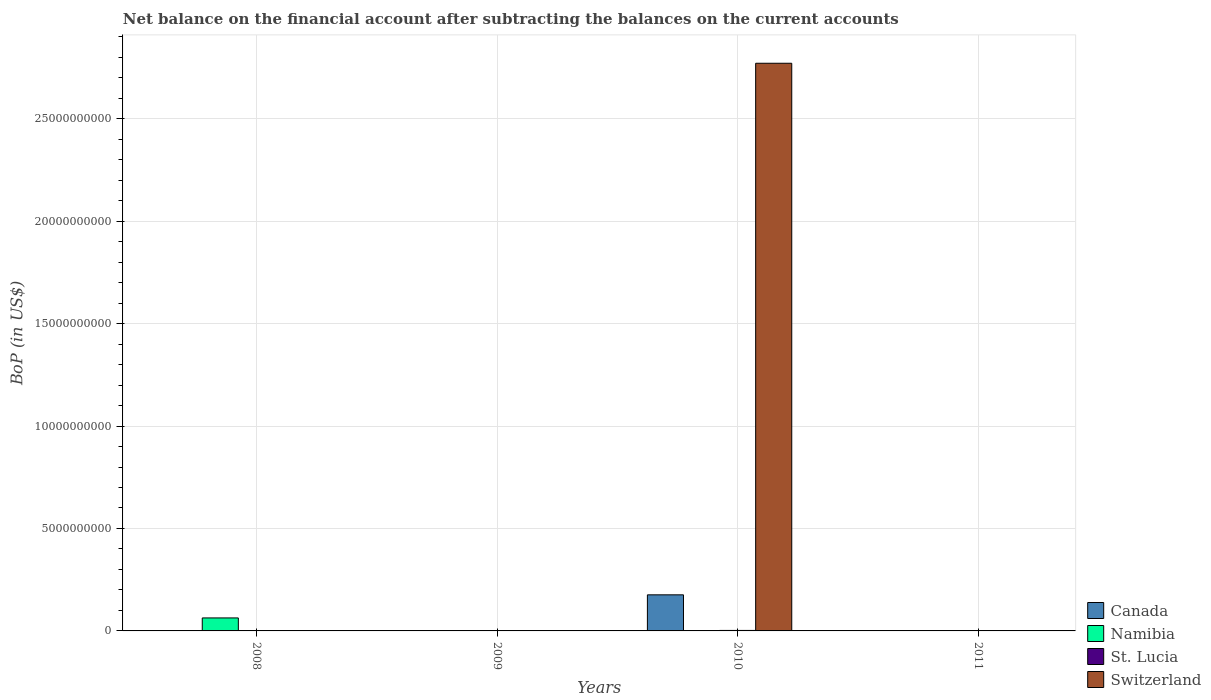Are the number of bars on each tick of the X-axis equal?
Your response must be concise. No. How many bars are there on the 3rd tick from the right?
Make the answer very short. 0. In how many cases, is the number of bars for a given year not equal to the number of legend labels?
Ensure brevity in your answer.  4. Across all years, what is the maximum Balance of Payments in Canada?
Your answer should be very brief. 1.76e+09. Across all years, what is the minimum Balance of Payments in Switzerland?
Your response must be concise. 0. In which year was the Balance of Payments in St. Lucia maximum?
Ensure brevity in your answer.  2010. What is the total Balance of Payments in Namibia in the graph?
Provide a short and direct response. 6.34e+08. What is the difference between the Balance of Payments in St. Lucia in 2011 and the Balance of Payments in Switzerland in 2010?
Provide a succinct answer. -2.77e+1. What is the average Balance of Payments in St. Lucia per year?
Offer a terse response. 8.04e+06. In the year 2010, what is the difference between the Balance of Payments in St. Lucia and Balance of Payments in Canada?
Provide a succinct answer. -1.74e+09. In how many years, is the Balance of Payments in St. Lucia greater than 14000000000 US$?
Provide a short and direct response. 0. Is the Balance of Payments in St. Lucia in 2010 less than that in 2011?
Offer a terse response. No. What is the difference between the highest and the lowest Balance of Payments in Canada?
Offer a terse response. 1.76e+09. Is it the case that in every year, the sum of the Balance of Payments in St. Lucia and Balance of Payments in Canada is greater than the Balance of Payments in Switzerland?
Offer a terse response. No. Where does the legend appear in the graph?
Your answer should be compact. Bottom right. How many legend labels are there?
Ensure brevity in your answer.  4. How are the legend labels stacked?
Make the answer very short. Vertical. What is the title of the graph?
Your answer should be compact. Net balance on the financial account after subtracting the balances on the current accounts. Does "United Kingdom" appear as one of the legend labels in the graph?
Keep it short and to the point. No. What is the label or title of the X-axis?
Your response must be concise. Years. What is the label or title of the Y-axis?
Provide a short and direct response. BoP (in US$). What is the BoP (in US$) of Canada in 2008?
Make the answer very short. 0. What is the BoP (in US$) in Namibia in 2008?
Your response must be concise. 6.34e+08. What is the BoP (in US$) in St. Lucia in 2008?
Ensure brevity in your answer.  0. What is the BoP (in US$) in Namibia in 2009?
Ensure brevity in your answer.  0. What is the BoP (in US$) of Switzerland in 2009?
Your answer should be very brief. 0. What is the BoP (in US$) of Canada in 2010?
Provide a succinct answer. 1.76e+09. What is the BoP (in US$) in Namibia in 2010?
Your answer should be very brief. 0. What is the BoP (in US$) of St. Lucia in 2010?
Your response must be concise. 2.43e+07. What is the BoP (in US$) of Switzerland in 2010?
Your answer should be very brief. 2.77e+1. What is the BoP (in US$) in Canada in 2011?
Your response must be concise. 0. What is the BoP (in US$) of Namibia in 2011?
Your response must be concise. 0. What is the BoP (in US$) of St. Lucia in 2011?
Offer a very short reply. 7.85e+06. Across all years, what is the maximum BoP (in US$) of Canada?
Your response must be concise. 1.76e+09. Across all years, what is the maximum BoP (in US$) of Namibia?
Your answer should be very brief. 6.34e+08. Across all years, what is the maximum BoP (in US$) in St. Lucia?
Provide a short and direct response. 2.43e+07. Across all years, what is the maximum BoP (in US$) of Switzerland?
Give a very brief answer. 2.77e+1. Across all years, what is the minimum BoP (in US$) of Canada?
Offer a very short reply. 0. Across all years, what is the minimum BoP (in US$) in St. Lucia?
Ensure brevity in your answer.  0. What is the total BoP (in US$) of Canada in the graph?
Keep it short and to the point. 1.76e+09. What is the total BoP (in US$) in Namibia in the graph?
Your answer should be very brief. 6.34e+08. What is the total BoP (in US$) of St. Lucia in the graph?
Ensure brevity in your answer.  3.22e+07. What is the total BoP (in US$) in Switzerland in the graph?
Offer a very short reply. 2.77e+1. What is the difference between the BoP (in US$) in St. Lucia in 2010 and that in 2011?
Your answer should be compact. 1.64e+07. What is the difference between the BoP (in US$) of Namibia in 2008 and the BoP (in US$) of St. Lucia in 2010?
Offer a terse response. 6.10e+08. What is the difference between the BoP (in US$) of Namibia in 2008 and the BoP (in US$) of Switzerland in 2010?
Provide a short and direct response. -2.71e+1. What is the difference between the BoP (in US$) in Namibia in 2008 and the BoP (in US$) in St. Lucia in 2011?
Make the answer very short. 6.26e+08. What is the difference between the BoP (in US$) in Canada in 2010 and the BoP (in US$) in St. Lucia in 2011?
Give a very brief answer. 1.75e+09. What is the average BoP (in US$) of Canada per year?
Provide a short and direct response. 4.40e+08. What is the average BoP (in US$) of Namibia per year?
Offer a terse response. 1.58e+08. What is the average BoP (in US$) in St. Lucia per year?
Offer a very short reply. 8.04e+06. What is the average BoP (in US$) of Switzerland per year?
Provide a short and direct response. 6.93e+09. In the year 2010, what is the difference between the BoP (in US$) in Canada and BoP (in US$) in St. Lucia?
Your response must be concise. 1.74e+09. In the year 2010, what is the difference between the BoP (in US$) in Canada and BoP (in US$) in Switzerland?
Make the answer very short. -2.59e+1. In the year 2010, what is the difference between the BoP (in US$) of St. Lucia and BoP (in US$) of Switzerland?
Your answer should be compact. -2.77e+1. What is the ratio of the BoP (in US$) of St. Lucia in 2010 to that in 2011?
Offer a very short reply. 3.09. What is the difference between the highest and the lowest BoP (in US$) in Canada?
Keep it short and to the point. 1.76e+09. What is the difference between the highest and the lowest BoP (in US$) of Namibia?
Make the answer very short. 6.34e+08. What is the difference between the highest and the lowest BoP (in US$) of St. Lucia?
Offer a terse response. 2.43e+07. What is the difference between the highest and the lowest BoP (in US$) of Switzerland?
Offer a very short reply. 2.77e+1. 